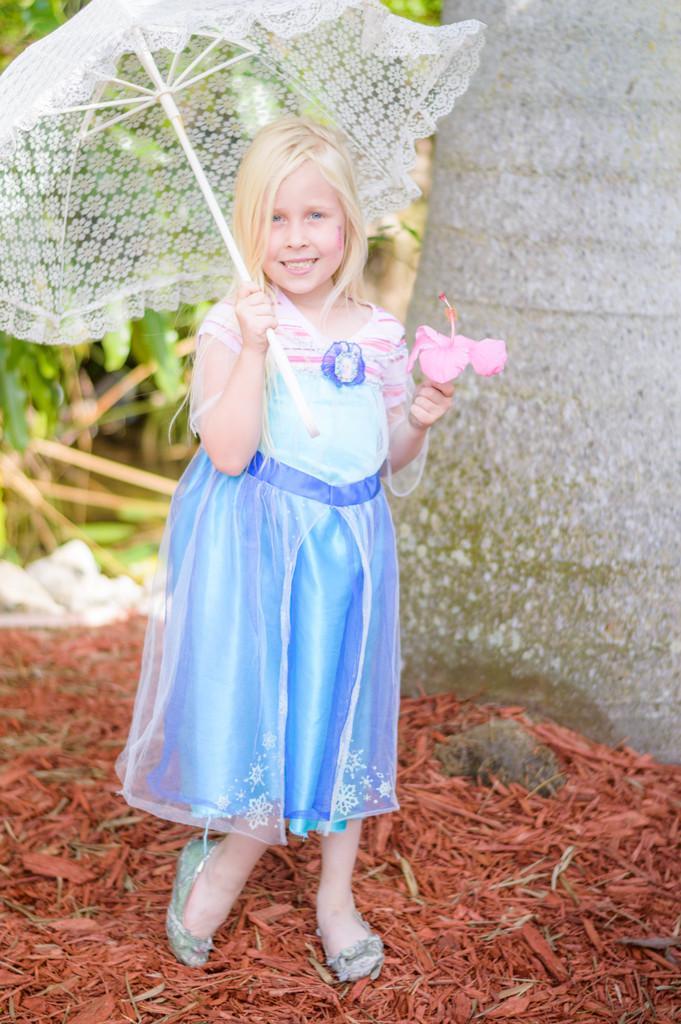How would you summarize this image in a sentence or two? In this picture we can see a girl standing and smiling and holding a flower and an umbrella with her hands and in the background we can see leaves, wall. 